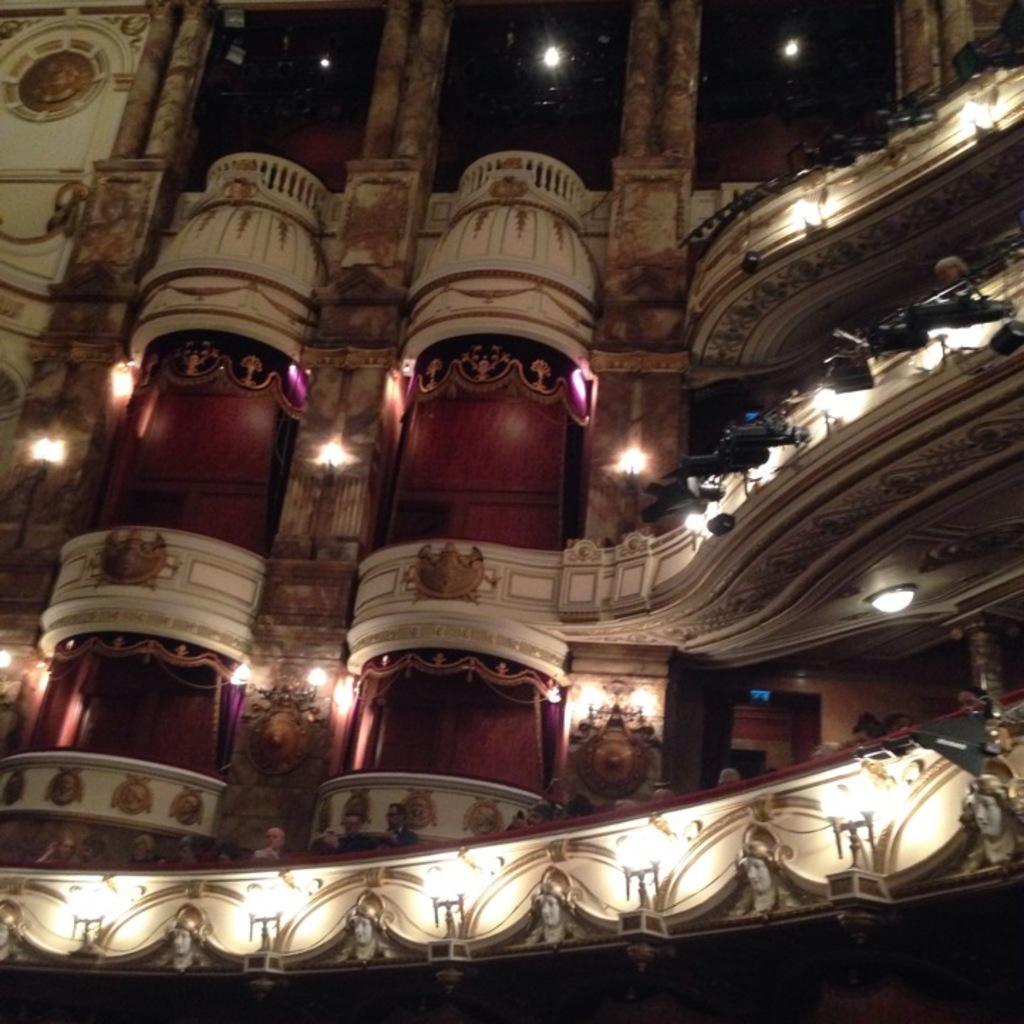How would you summarize this image in a sentence or two? In this picture we can see a building, carvings on them and lights. We can also see people. 